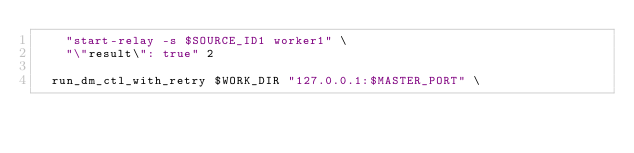Convert code to text. <code><loc_0><loc_0><loc_500><loc_500><_Bash_>		"start-relay -s $SOURCE_ID1 worker1" \
		"\"result\": true" 2

	run_dm_ctl_with_retry $WORK_DIR "127.0.0.1:$MASTER_PORT" \</code> 